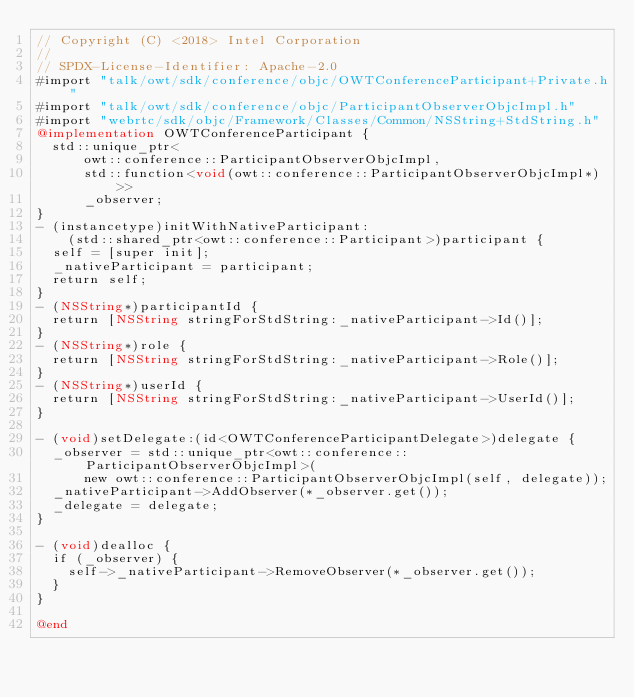Convert code to text. <code><loc_0><loc_0><loc_500><loc_500><_ObjectiveC_>// Copyright (C) <2018> Intel Corporation
//
// SPDX-License-Identifier: Apache-2.0
#import "talk/owt/sdk/conference/objc/OWTConferenceParticipant+Private.h"
#import "talk/owt/sdk/conference/objc/ParticipantObserverObjcImpl.h"
#import "webrtc/sdk/objc/Framework/Classes/Common/NSString+StdString.h"
@implementation OWTConferenceParticipant {
  std::unique_ptr<
      owt::conference::ParticipantObserverObjcImpl,
      std::function<void(owt::conference::ParticipantObserverObjcImpl*)>>
      _observer;
}
- (instancetype)initWithNativeParticipant:
    (std::shared_ptr<owt::conference::Participant>)participant {
  self = [super init];
  _nativeParticipant = participant;
  return self;
}
- (NSString*)participantId {
  return [NSString stringForStdString:_nativeParticipant->Id()];
}
- (NSString*)role {
  return [NSString stringForStdString:_nativeParticipant->Role()];
}
- (NSString*)userId {
  return [NSString stringForStdString:_nativeParticipant->UserId()];
}

- (void)setDelegate:(id<OWTConferenceParticipantDelegate>)delegate {
  _observer = std::unique_ptr<owt::conference::ParticipantObserverObjcImpl>(
      new owt::conference::ParticipantObserverObjcImpl(self, delegate));
  _nativeParticipant->AddObserver(*_observer.get());
  _delegate = delegate;
}

- (void)dealloc {
  if (_observer) {
    self->_nativeParticipant->RemoveObserver(*_observer.get());
  }
}

@end
</code> 